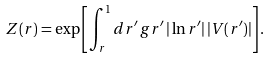Convert formula to latex. <formula><loc_0><loc_0><loc_500><loc_500>Z ( r ) = \exp \left [ \int _ { r } ^ { 1 } d r ^ { \prime } \, g r ^ { \prime } \, | \ln r ^ { \prime } | \, | V ( r ^ { \prime } ) | \right ] .</formula> 